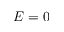<formula> <loc_0><loc_0><loc_500><loc_500>E = 0</formula> 